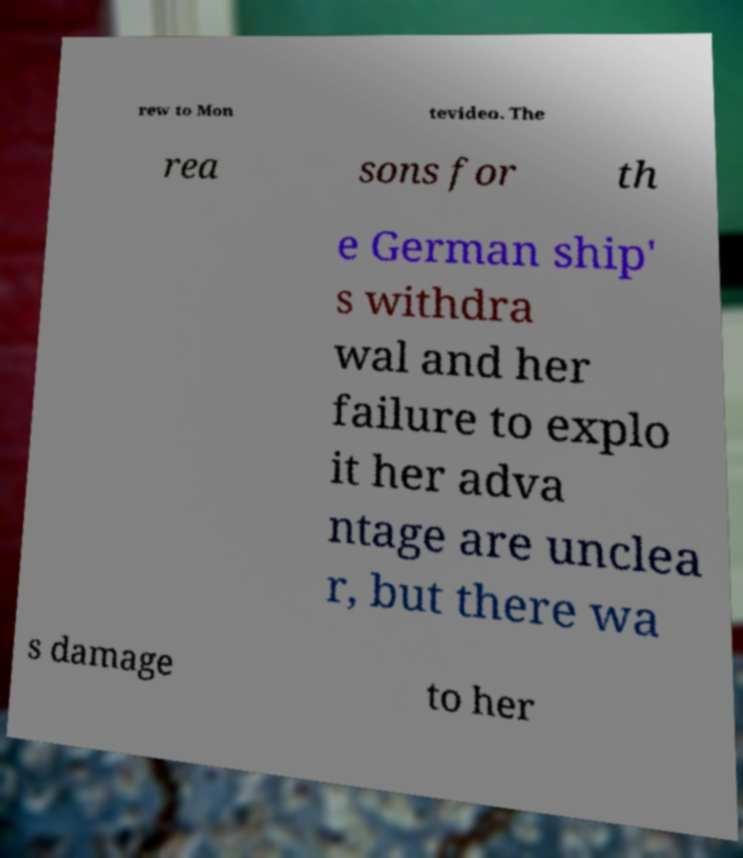I need the written content from this picture converted into text. Can you do that? rew to Mon tevideo. The rea sons for th e German ship' s withdra wal and her failure to explo it her adva ntage are unclea r, but there wa s damage to her 